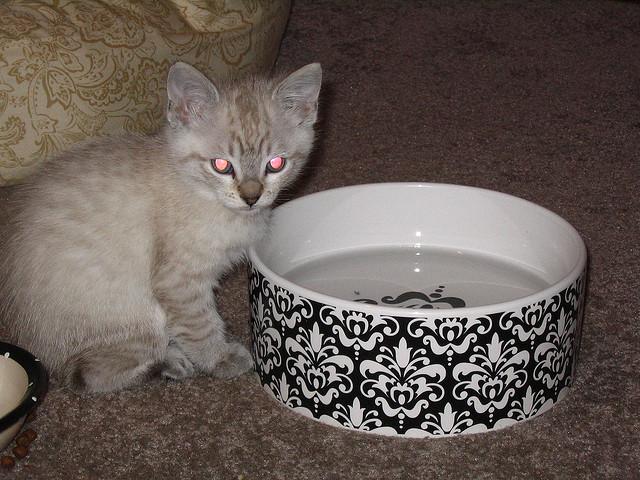How many bowls does the cat have?
Quick response, please. 1. What color is the carpet on the floor?
Short answer required. Brown. Will the cat eat all of the food?
Quick response, please. No. Why are the cat's eyes red?
Concise answer only. Camera flash. Could this cat fit in the water bowl?
Concise answer only. Yes. 